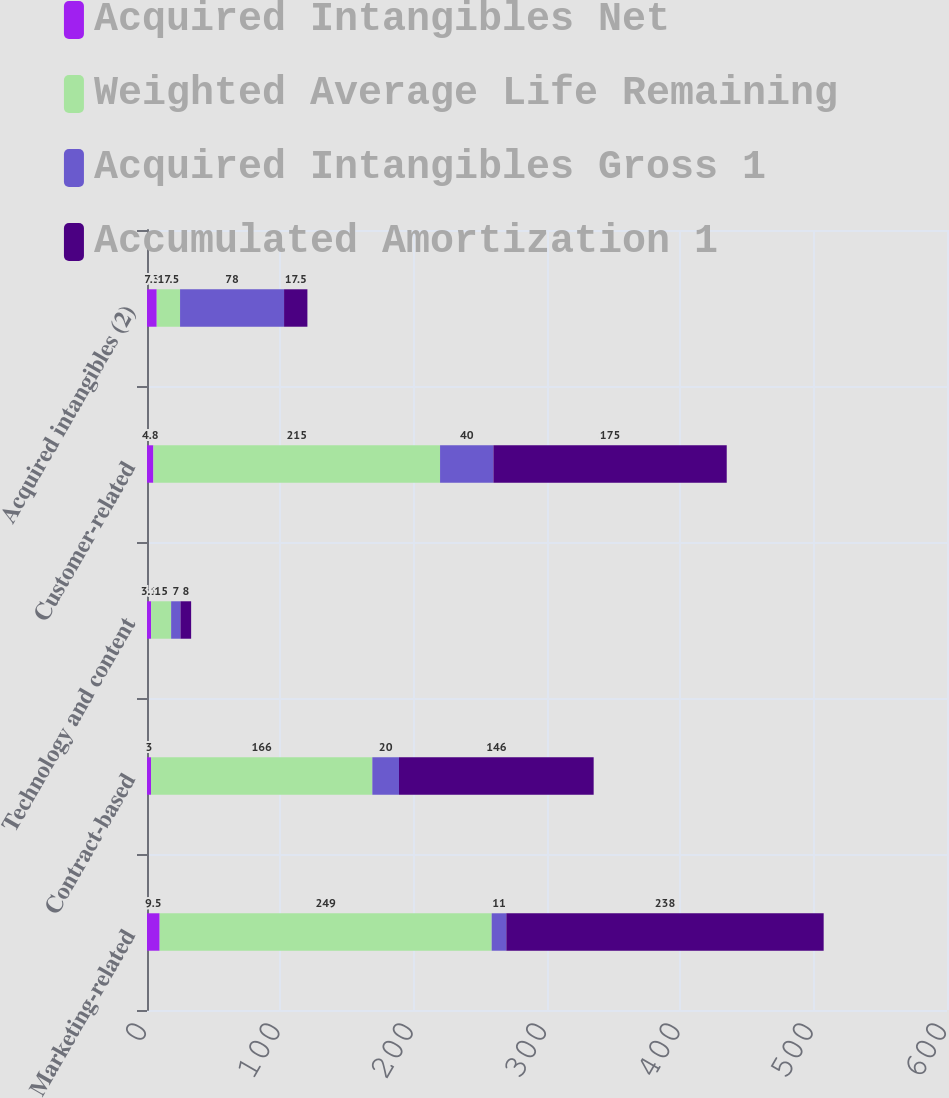Convert chart. <chart><loc_0><loc_0><loc_500><loc_500><stacked_bar_chart><ecel><fcel>Marketing-related<fcel>Contract-based<fcel>Technology and content<fcel>Customer-related<fcel>Acquired intangibles (2)<nl><fcel>Acquired Intangibles Net<fcel>9.5<fcel>3<fcel>3.1<fcel>4.8<fcel>7.3<nl><fcel>Weighted Average Life Remaining<fcel>249<fcel>166<fcel>15<fcel>215<fcel>17.5<nl><fcel>Acquired Intangibles Gross 1<fcel>11<fcel>20<fcel>7<fcel>40<fcel>78<nl><fcel>Accumulated Amortization 1<fcel>238<fcel>146<fcel>8<fcel>175<fcel>17.5<nl></chart> 